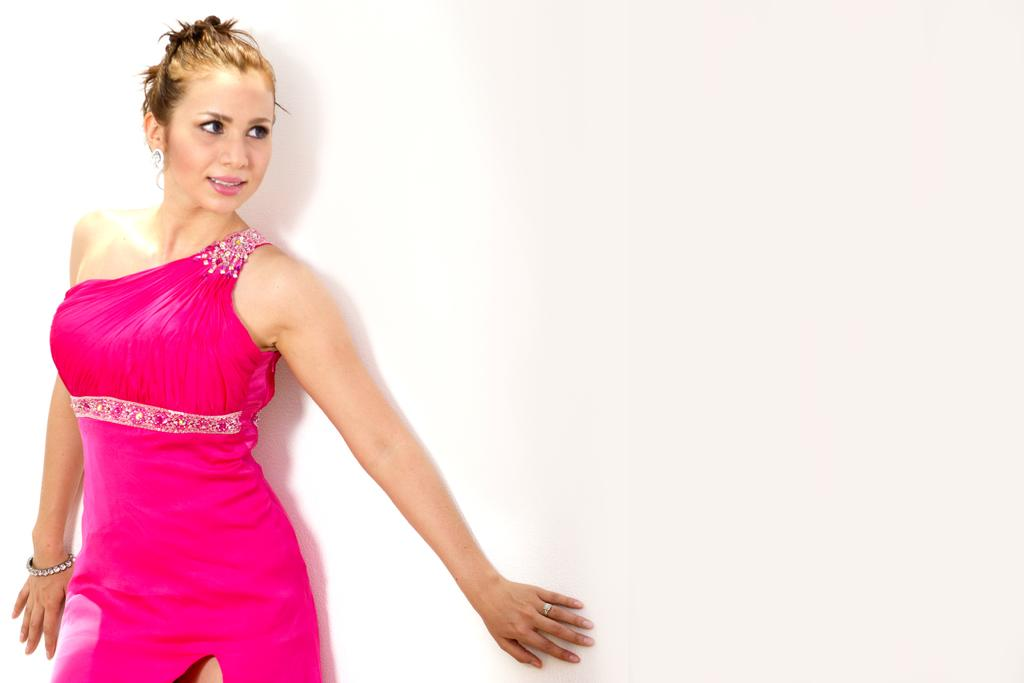What is the main subject of the image? There is a woman standing in the image. What can be seen in the background of the image? The background of the image is white. Can you see a stream flowing in the background of the image? No, there is no stream present in the image. The background is white, and there is no indication of a stream or any other natural elements. 